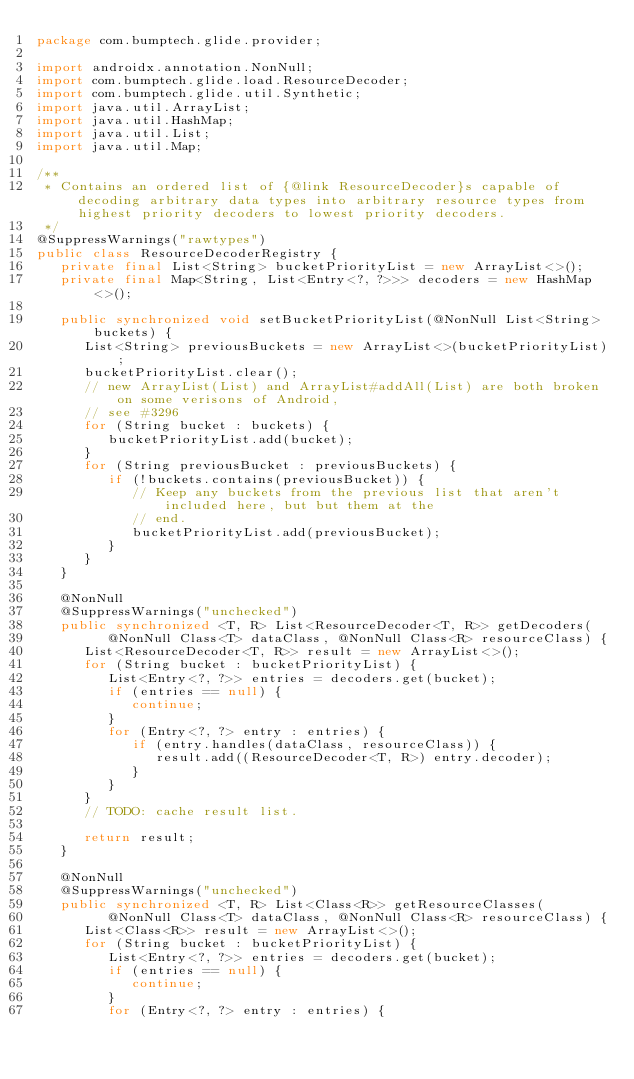<code> <loc_0><loc_0><loc_500><loc_500><_Java_>package com.bumptech.glide.provider;

import androidx.annotation.NonNull;
import com.bumptech.glide.load.ResourceDecoder;
import com.bumptech.glide.util.Synthetic;
import java.util.ArrayList;
import java.util.HashMap;
import java.util.List;
import java.util.Map;

/**
 * Contains an ordered list of {@link ResourceDecoder}s capable of decoding arbitrary data types into arbitrary resource types from highest priority decoders to lowest priority decoders.
 */
@SuppressWarnings("rawtypes")
public class ResourceDecoderRegistry {
   private final List<String> bucketPriorityList = new ArrayList<>();
   private final Map<String, List<Entry<?, ?>>> decoders = new HashMap<>();

   public synchronized void setBucketPriorityList(@NonNull List<String> buckets) {
      List<String> previousBuckets = new ArrayList<>(bucketPriorityList);
      bucketPriorityList.clear();
      // new ArrayList(List) and ArrayList#addAll(List) are both broken on some verisons of Android,
      // see #3296
      for (String bucket : buckets) {
         bucketPriorityList.add(bucket);
      }
      for (String previousBucket : previousBuckets) {
         if (!buckets.contains(previousBucket)) {
            // Keep any buckets from the previous list that aren't included here, but but them at the
            // end.
            bucketPriorityList.add(previousBucket);
         }
      }
   }

   @NonNull
   @SuppressWarnings("unchecked")
   public synchronized <T, R> List<ResourceDecoder<T, R>> getDecoders(
         @NonNull Class<T> dataClass, @NonNull Class<R> resourceClass) {
      List<ResourceDecoder<T, R>> result = new ArrayList<>();
      for (String bucket : bucketPriorityList) {
         List<Entry<?, ?>> entries = decoders.get(bucket);
         if (entries == null) {
            continue;
         }
         for (Entry<?, ?> entry : entries) {
            if (entry.handles(dataClass, resourceClass)) {
               result.add((ResourceDecoder<T, R>) entry.decoder);
            }
         }
      }
      // TODO: cache result list.

      return result;
   }

   @NonNull
   @SuppressWarnings("unchecked")
   public synchronized <T, R> List<Class<R>> getResourceClasses(
         @NonNull Class<T> dataClass, @NonNull Class<R> resourceClass) {
      List<Class<R>> result = new ArrayList<>();
      for (String bucket : bucketPriorityList) {
         List<Entry<?, ?>> entries = decoders.get(bucket);
         if (entries == null) {
            continue;
         }
         for (Entry<?, ?> entry : entries) {</code> 